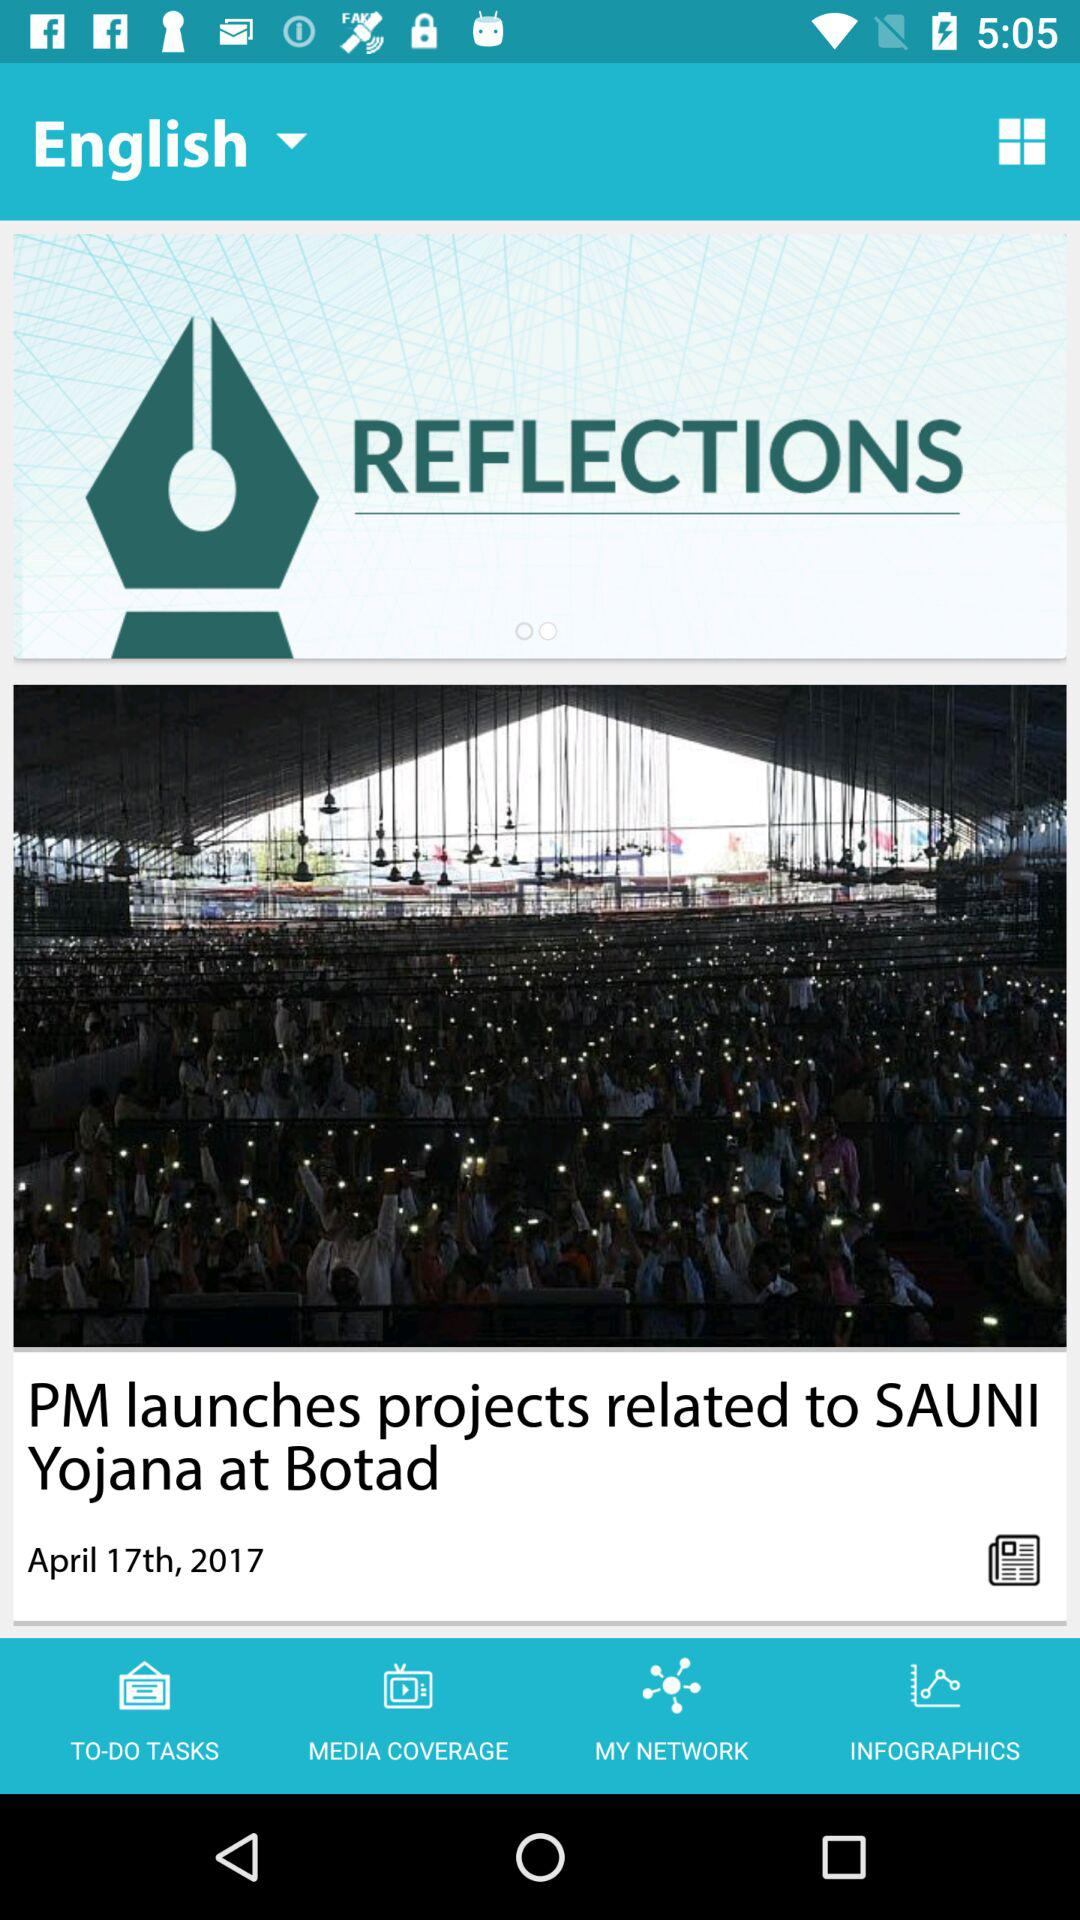What is the name of the Yojana that the PM launches? The name of the Yojana is "SAUNI Yojana". 